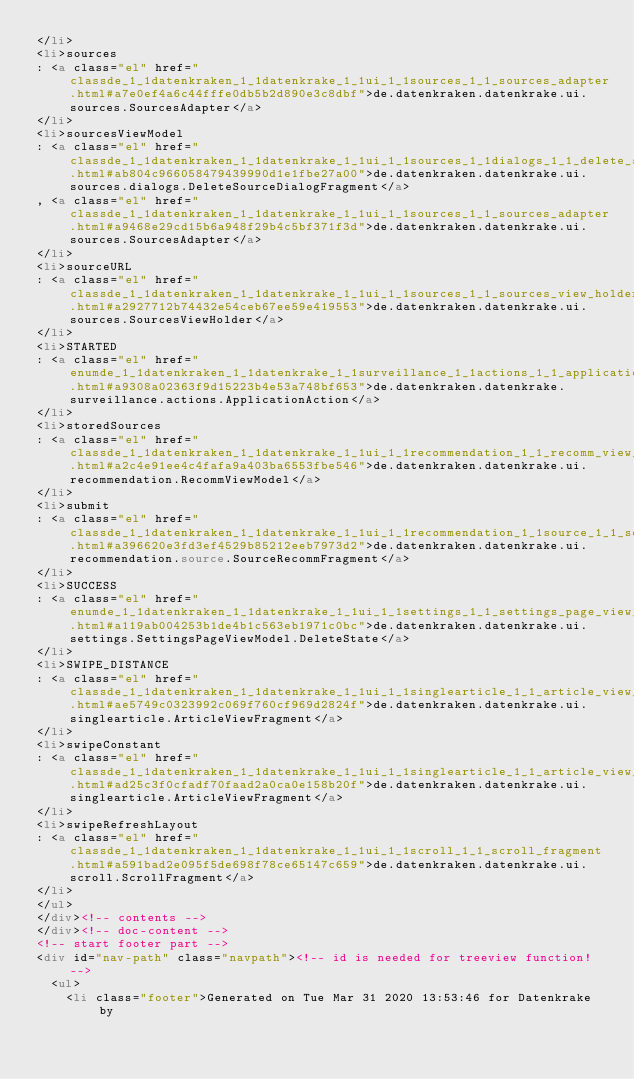<code> <loc_0><loc_0><loc_500><loc_500><_HTML_></li>
<li>sources
: <a class="el" href="classde_1_1datenkraken_1_1datenkrake_1_1ui_1_1sources_1_1_sources_adapter.html#a7e0ef4a6c44fffe0db5b2d890e3c8dbf">de.datenkraken.datenkrake.ui.sources.SourcesAdapter</a>
</li>
<li>sourcesViewModel
: <a class="el" href="classde_1_1datenkraken_1_1datenkrake_1_1ui_1_1sources_1_1dialogs_1_1_delete_source_dialog_fragment.html#ab804c966058479439990d1e1fbe27a00">de.datenkraken.datenkrake.ui.sources.dialogs.DeleteSourceDialogFragment</a>
, <a class="el" href="classde_1_1datenkraken_1_1datenkrake_1_1ui_1_1sources_1_1_sources_adapter.html#a9468e29cd15b6a948f29b4c5bf371f3d">de.datenkraken.datenkrake.ui.sources.SourcesAdapter</a>
</li>
<li>sourceURL
: <a class="el" href="classde_1_1datenkraken_1_1datenkrake_1_1ui_1_1sources_1_1_sources_view_holder.html#a2927712b74432e54ceb67ee59e419553">de.datenkraken.datenkrake.ui.sources.SourcesViewHolder</a>
</li>
<li>STARTED
: <a class="el" href="enumde_1_1datenkraken_1_1datenkrake_1_1surveillance_1_1actions_1_1_application_action.html#a9308a02363f9d15223b4e53a748bf653">de.datenkraken.datenkrake.surveillance.actions.ApplicationAction</a>
</li>
<li>storedSources
: <a class="el" href="classde_1_1datenkraken_1_1datenkrake_1_1ui_1_1recommendation_1_1_recomm_view_model.html#a2c4e91ee4c4fafa9a403ba6553fbe546">de.datenkraken.datenkrake.ui.recommendation.RecommViewModel</a>
</li>
<li>submit
: <a class="el" href="classde_1_1datenkraken_1_1datenkrake_1_1ui_1_1recommendation_1_1source_1_1_source_recomm_fragment.html#a396620e3fd3ef4529b85212eeb7973d2">de.datenkraken.datenkrake.ui.recommendation.source.SourceRecommFragment</a>
</li>
<li>SUCCESS
: <a class="el" href="enumde_1_1datenkraken_1_1datenkrake_1_1ui_1_1settings_1_1_settings_page_view_model_1_1_delete_state.html#a119ab004253b1de4b1c563eb1971c0bc">de.datenkraken.datenkrake.ui.settings.SettingsPageViewModel.DeleteState</a>
</li>
<li>SWIPE_DISTANCE
: <a class="el" href="classde_1_1datenkraken_1_1datenkrake_1_1ui_1_1singlearticle_1_1_article_view_fragment.html#ae5749c0323992c069f760cf969d2824f">de.datenkraken.datenkrake.ui.singlearticle.ArticleViewFragment</a>
</li>
<li>swipeConstant
: <a class="el" href="classde_1_1datenkraken_1_1datenkrake_1_1ui_1_1singlearticle_1_1_article_view_fragment.html#ad25c3f0cfadf70faad2a0ca0e158b20f">de.datenkraken.datenkrake.ui.singlearticle.ArticleViewFragment</a>
</li>
<li>swipeRefreshLayout
: <a class="el" href="classde_1_1datenkraken_1_1datenkrake_1_1ui_1_1scroll_1_1_scroll_fragment.html#a591bad2e095f5de698f78ce65147c659">de.datenkraken.datenkrake.ui.scroll.ScrollFragment</a>
</li>
</ul>
</div><!-- contents -->
</div><!-- doc-content -->
<!-- start footer part -->
<div id="nav-path" class="navpath"><!-- id is needed for treeview function! -->
  <ul>
    <li class="footer">Generated on Tue Mar 31 2020 13:53:46 for Datenkrake by</code> 